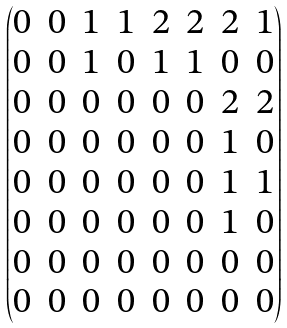Convert formula to latex. <formula><loc_0><loc_0><loc_500><loc_500>\begin{pmatrix} 0 & 0 & 1 & 1 & 2 & 2 & 2 & 1 \\ 0 & 0 & 1 & 0 & 1 & 1 & 0 & 0 \\ 0 & 0 & 0 & 0 & 0 & 0 & 2 & 2 \\ 0 & 0 & 0 & 0 & 0 & 0 & 1 & 0 \\ 0 & 0 & 0 & 0 & 0 & 0 & 1 & 1 \\ 0 & 0 & 0 & 0 & 0 & 0 & 1 & 0 \\ 0 & 0 & 0 & 0 & 0 & 0 & 0 & 0 \\ 0 & 0 & 0 & 0 & 0 & 0 & 0 & 0 \end{pmatrix}</formula> 